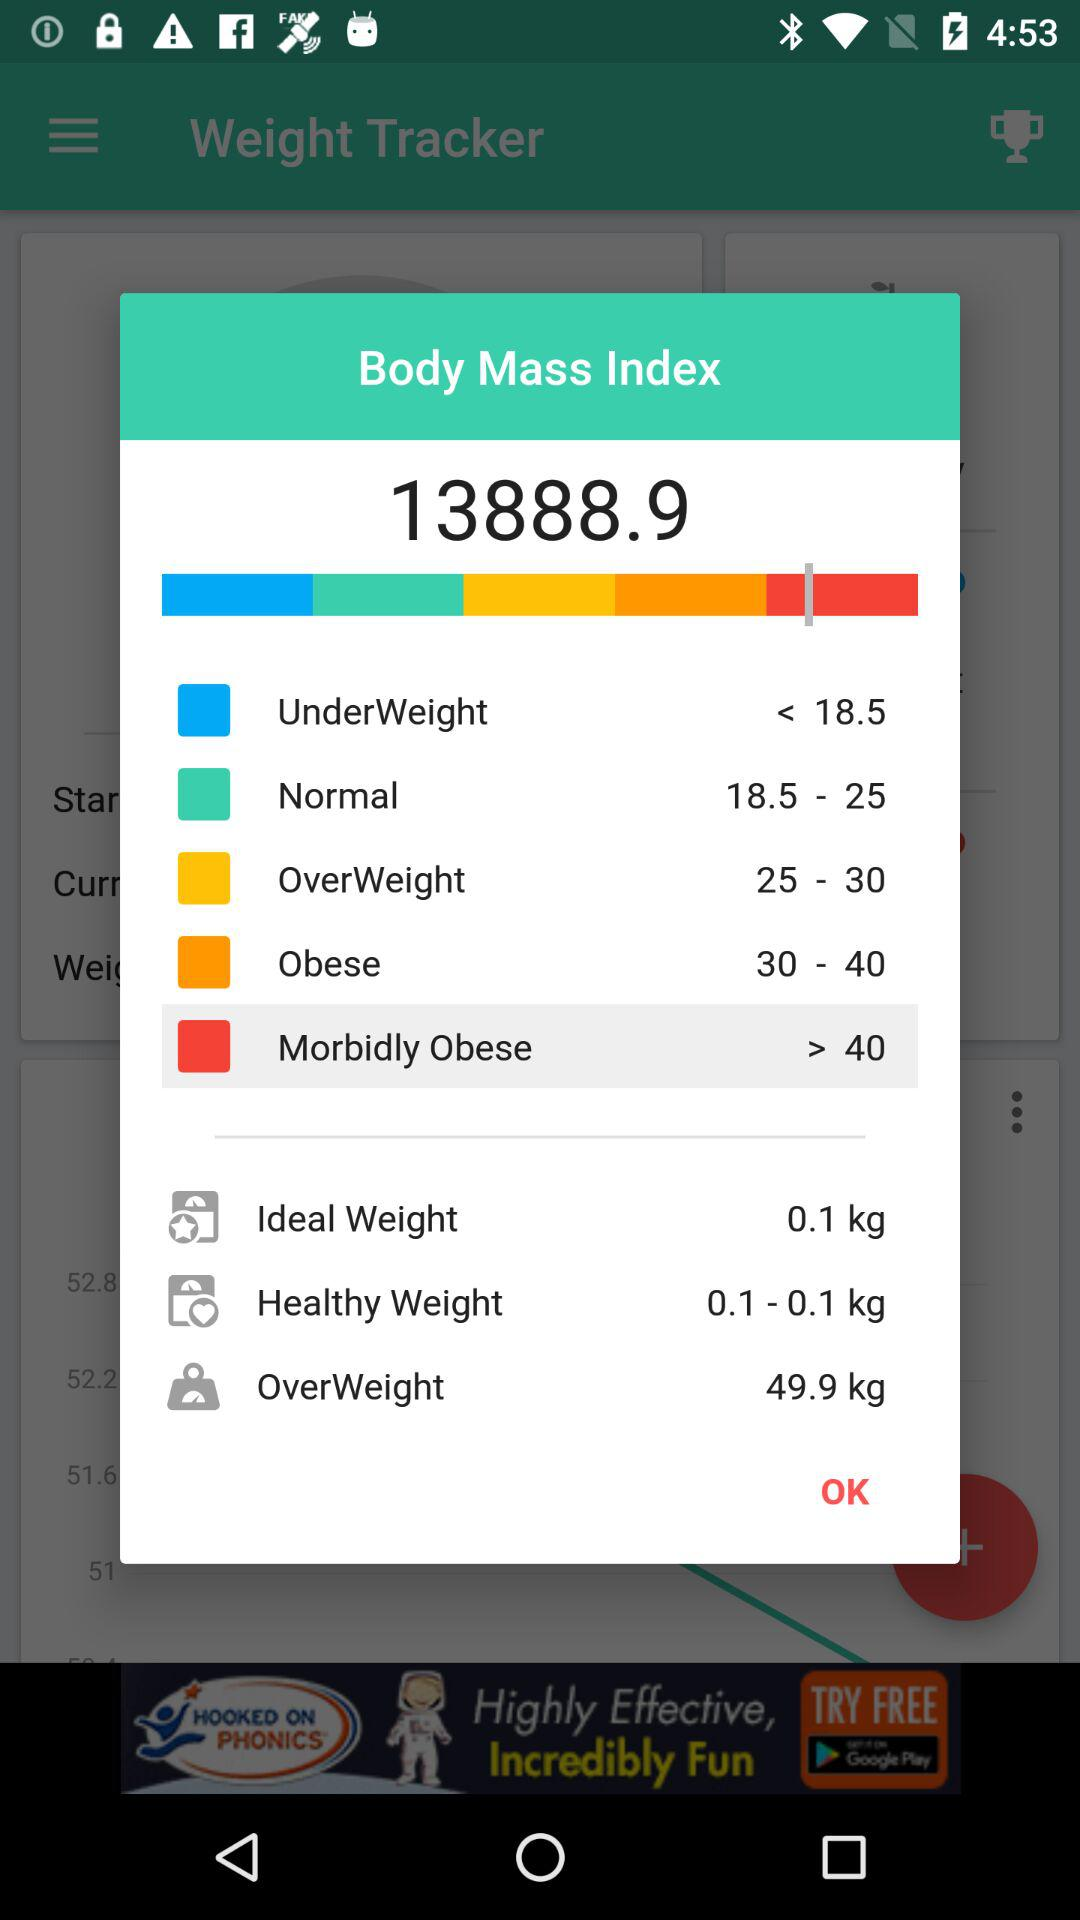What is the weight range for Obese? The weight range is from 30 to 40. 